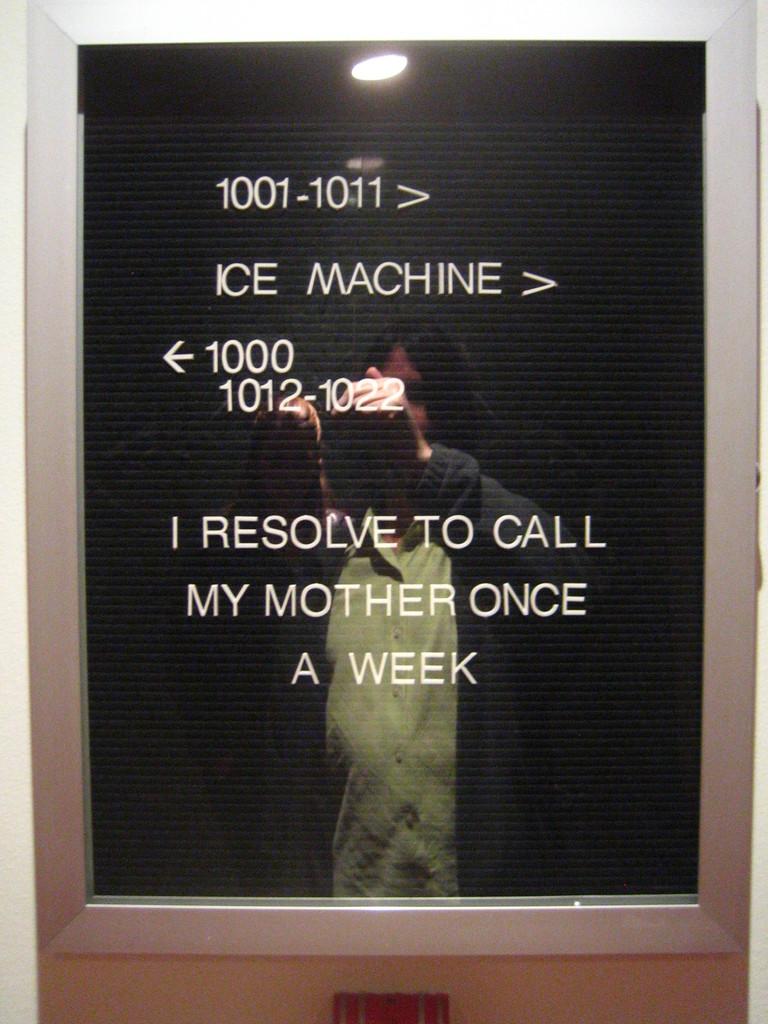What kind of machine will you find if you go right?
Keep it short and to the point. Ice. Who will the person call once a week?
Make the answer very short. Mother. 